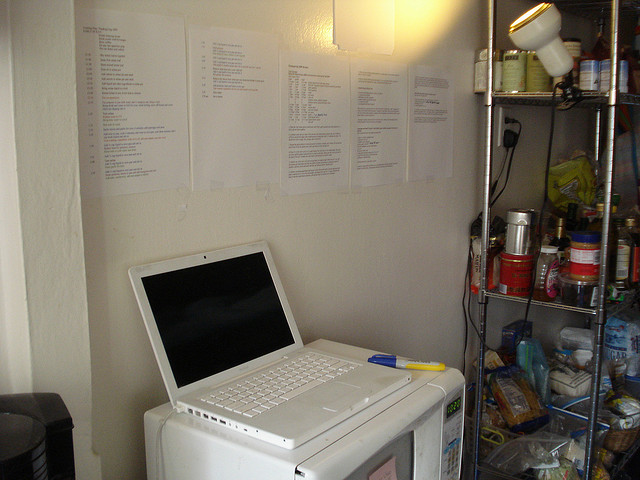The scene looks busy and packed with items. Can you imagine a story where all these items play a central role in a quirky situation? Absolutely! Picture this: a struggling inventor named Alex sets up their tiny apartment to function as both a laboratory and a kitchen. One day, while preparing a new blend of energizing coffee using their coffee maker, they accidentally knock over the jar of honey. The jar lands on the glowing, warm laptop, triggering an unintended reaction in their latest experiment projected on the screen. To save the day, Alex has to use creative engineering skills to repurpose the microwave into a makeshift decontamination chamber. In the midst of all this commotion, Alex realizes that the printed documents on the wall, which were initially disregarded as mundane to-do lists, actually have encoded messages from a parallel universe! Throughout this hilarious chaos, Alex learns the true blend of focus and fun in their creative endeavours. 